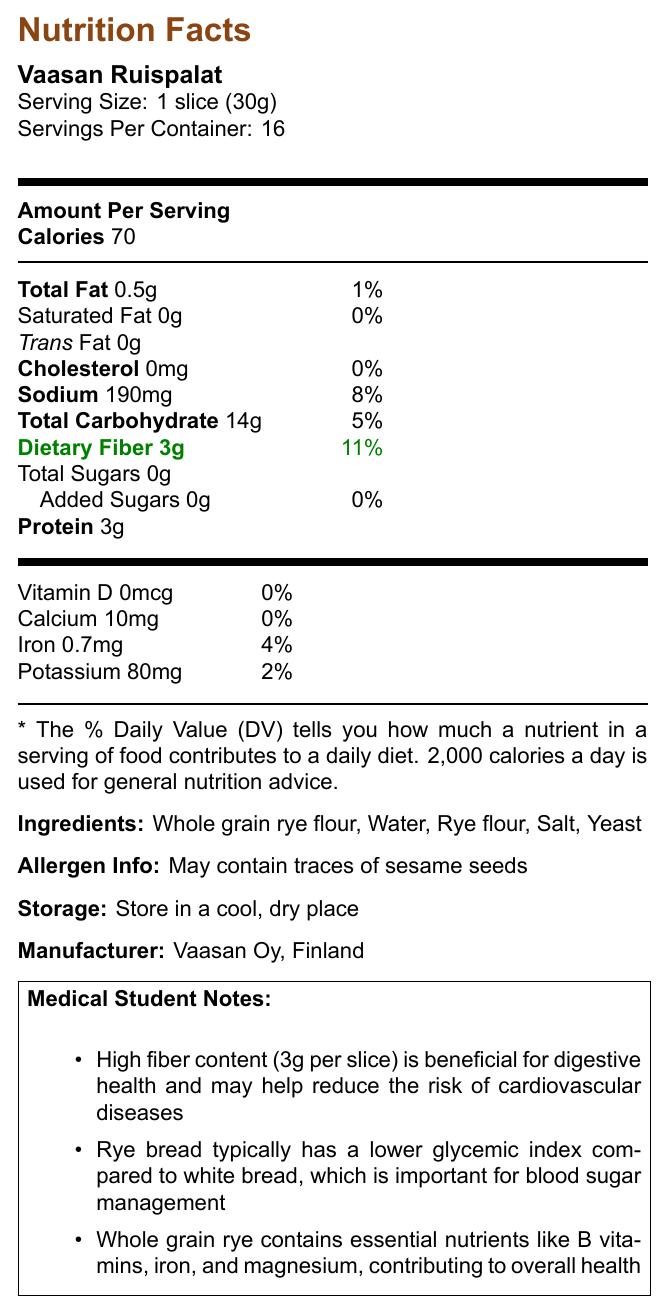what is the serving size? The serving size is mentioned at the beginning of the document under the product name "Vaasan Ruispalat".
Answer: 1 slice (30g) how many calories are in one serving? The number of calories per serving is listed right after the "Amount Per Serving" section.
Answer: 70 calories what is the total fat content per serving in grams? The total fat content per serving is specified in the "Total Fat" section with the measurement "0.5g".
Answer: 0.5g what is the dietary fiber content per serving? The dietary fiber content is highlighted in green and is stated as "Dietary Fiber 3g".
Answer: 3g how much protein does one serving contain? The protein content per serving is listed under the "Protein" section with the measurement "3g".
Answer: 3g which ingredient is listed first? A. Salt B. Water C. Rye flour D. Whole grain rye flour The ingredients list starts with "Whole grain rye flour".
Answer: D which vitamin or mineral has a daily value percentage of 4%? A. Vitamin D B. Calcium C. Iron D. Potassium The daily value percentage of 4% corresponds to Iron, as detailed in the vitamins and minerals section.
Answer: C what percentage of the daily value is the sodium content per serving? The sodium content per serving is listed as 190mg, which accounts for 8% of the daily value.
Answer: 8% Is the product gluten-free? According to the additional information section, this product is not gluten-free.
Answer: No Is there any cholesterol in one serving? The cholesterol content is listed as 0mg, which means there is no cholesterol in one serving.
Answer: No summarize the main idea of the document The summary covers all the essential sections mentioned in the document including nutritional values, ingredients, allergens, storage instructions, manufacturer details, and health-related notes.
Answer: The document provides the nutrition facts and additional information for Vaasan Ruispalat rye bread. It includes details about serving size, calories, macronutrient and micronutrient content, ingredients, allergen information, storage instructions, and notable health benefits according to medical student notes. what is the country of origin of the product? The country of origin is specified at the bottom of the document stating "Vaasan Oy, Finland."
Answer: Finland what impact does the high fiber content have on health? The medical student notes highlight that high fiber content (3g per slice) is beneficial for digestive health and might help reduce the risk of cardiovascular diseases.
Answer: Beneficial for digestive health and may help reduce the risk of cardiovascular diseases does the product contain any added sugars? The document states that the product contains 0g of added sugars.
Answer: No Can the bread be stored at room temperature? The storage instructions indicate that the bread should be stored in a cool, dry place, which suggests that room temperature is acceptable if it meets these conditions.
Answer: Yes how many servings are there per container? The number of servings per container is listed as 16.
Answer: 16 what are the health benefits of whole grain rye mentioned in the notes? The medical student notes explain that whole grain rye contains essential nutrients such as B vitamins, iron, and magnesium, which contribute to overall health.
Answer: Contains essential nutrients like B vitamins, iron, and magnesium, contributing to overall health how much potassium is in one serving? The potassium content is listed under the vitamins and minerals section with the measurement "80mg".
Answer: 80mg Is the product organic? Under additional information, it is specified that the product is not organic.
Answer: No What is the glycemic index of rye bread compared to white bread? While the document notes that rye bread typically has a lower glycemic index compared to white bread, it does not provide specific values to quantify this difference.
Answer: Cannot be determined 